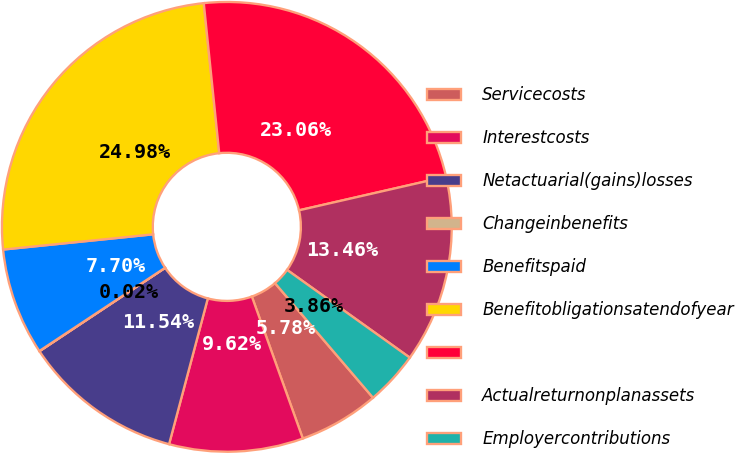Convert chart to OTSL. <chart><loc_0><loc_0><loc_500><loc_500><pie_chart><fcel>Servicecosts<fcel>Interestcosts<fcel>Netactuarial(gains)losses<fcel>Changeinbenefits<fcel>Benefitspaid<fcel>Benefitobligationsatendofyear<fcel>Unnamed: 6<fcel>Actualreturnonplanassets<fcel>Employercontributions<nl><fcel>5.78%<fcel>9.62%<fcel>11.54%<fcel>0.02%<fcel>7.7%<fcel>24.98%<fcel>23.06%<fcel>13.46%<fcel>3.86%<nl></chart> 